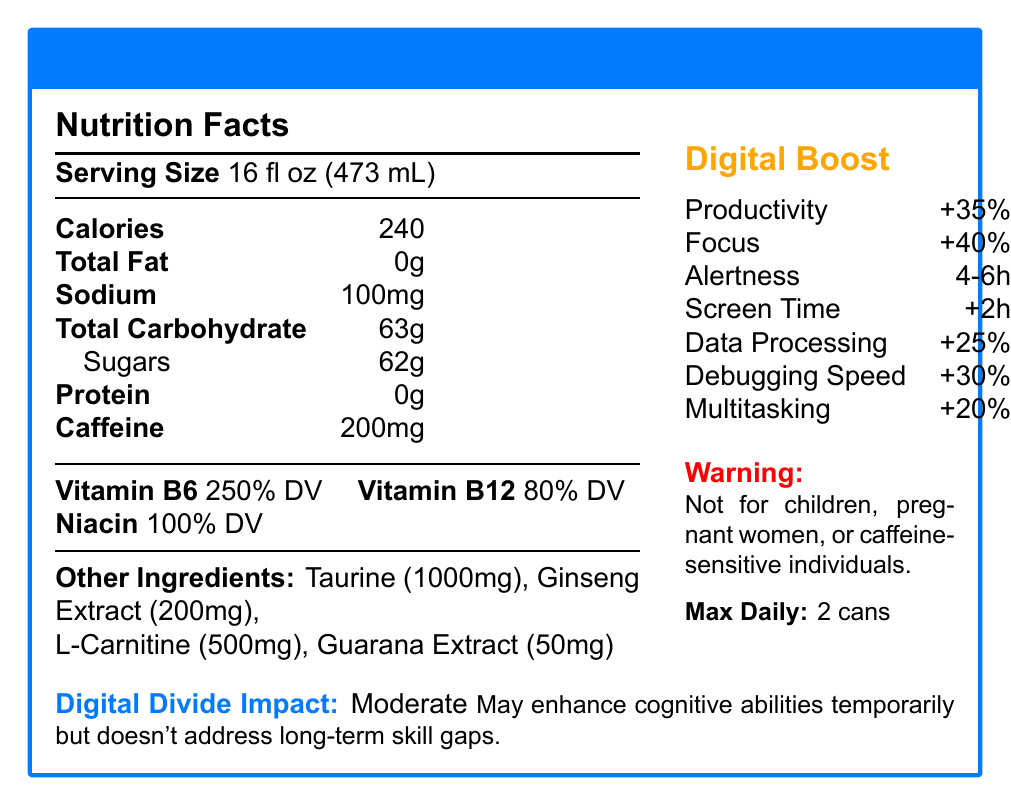what is the serving size of TechBoost Energy? The serving size is listed as "Serving Size" in the document.
Answer: 16 fl oz (473 mL) how many calories are in one serving of TechBoost Energy? The document states "Calories" as 240 per serving.
Answer: 240 what is the caffeine content of TechBoost Energy? The document lists the "Caffeine" content as 200mg.
Answer: 200mg what are the potential side effects of consuming TechBoost Energy? The document lists these potential side effects under "potential side effects."
Answer: Jitters, Increased heart rate, Difficulty sleeping if consumed late in the day how many servings are there per container of TechBoost Energy? The document mentions "servings per container: 1."
Answer: 1 what percentage of vitamin B6 does TechBoost Energy provide? The document lists "Vitamin B6" as 250% of the daily value.
Answer: 250% DV what other ingredients does TechBoost Energy contain besides caffeine? The document lists these ingredients under "Other Ingredients."
Answer: Taurine (1000mg), Ginseng Extract (200mg), L-Carnitine (500mg), Guarana Extract (50mg) how long does the mental alertness enhancement last after consuming TechBoost Energy? The duration of mental alertness is stated as "4-6 hours."
Answer: 4-6 hours how does consuming TechBoost Energy affect screen time tolerance? The document states that screen time tolerance increases by +2 hours.
Answer: +2 hours what is the recommended maximum daily intake of TechBoost Energy? The document states the "recommended daily intake" as no more than 2 cans per day.
Answer: No more than 2 cans per day what factors contribute to the digital divide impact of TechBoost Energy? A. Long-term cognitive improvement B. Temporary cognitive enhancement C. Skill gap elimination D. Physical exercise The document mentions that TechBoost Energy provides temporary cognitive enhancement but does not address long-term skill gaps.
Answer: B, D which improvement is the highest in percentage from consuming TechBoost Energy? A. Digital productivity boost B. Focus enhancement C. Multitasking capacity D. Data processing efficiency The document lists "focus enhancement" as 40%, which is the highest percentage improvement.
Answer: B true or false: TechBoost Energy is recommended for children and pregnant women. The document clearly states "Not recommended for children, pregnant women, or individuals sensitive to caffeine."
Answer: False summarize the main information provided in the document. The document provides detailed nutritional facts and performance enhancements of TechBoost Energy, alongside warnings and potential side effects, aiming to highlight its short-term benefits and limitations in addressing the digital divide.
Answer: TechBoost Energy is an energy drink with 240 calories per 16 fl oz serving and contains 200mg of caffeine along with other ingredients such as taurine and ginseng extract. It boosts digital productivity, focus, and mental alertness but comes with potential side effects like jitters. The recommended maximum daily intake is two cans, and it's not suitable for children, pregnant women, or those sensitive to caffeine. While it temporarily enhances cognitive abilities, it does not address long-term skill gaps. what is the exact boost in creativity after consuming TechBoost Energy? The document lists "creativity boost" as 10%.
Answer: 10% are there any details about the manufacturing process of TechBoost Energy in the document? The document does not provide any information regarding the manufacturing process.
Answer: Cannot be determined 